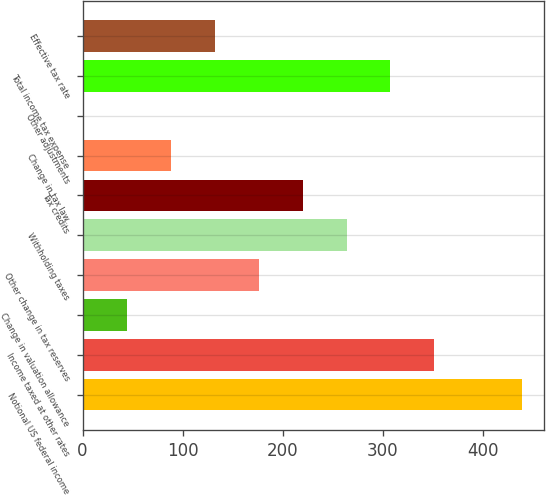Convert chart to OTSL. <chart><loc_0><loc_0><loc_500><loc_500><bar_chart><fcel>Notional US federal income<fcel>Income taxed at other rates<fcel>Change in valuation allowance<fcel>Other change in tax reserves<fcel>Withholding taxes<fcel>Tax credits<fcel>Change in tax law<fcel>Other adjustments<fcel>Total income tax expense<fcel>Effective tax rate<nl><fcel>439<fcel>351.4<fcel>44.8<fcel>176.2<fcel>263.8<fcel>220<fcel>88.6<fcel>1<fcel>307.6<fcel>132.4<nl></chart> 